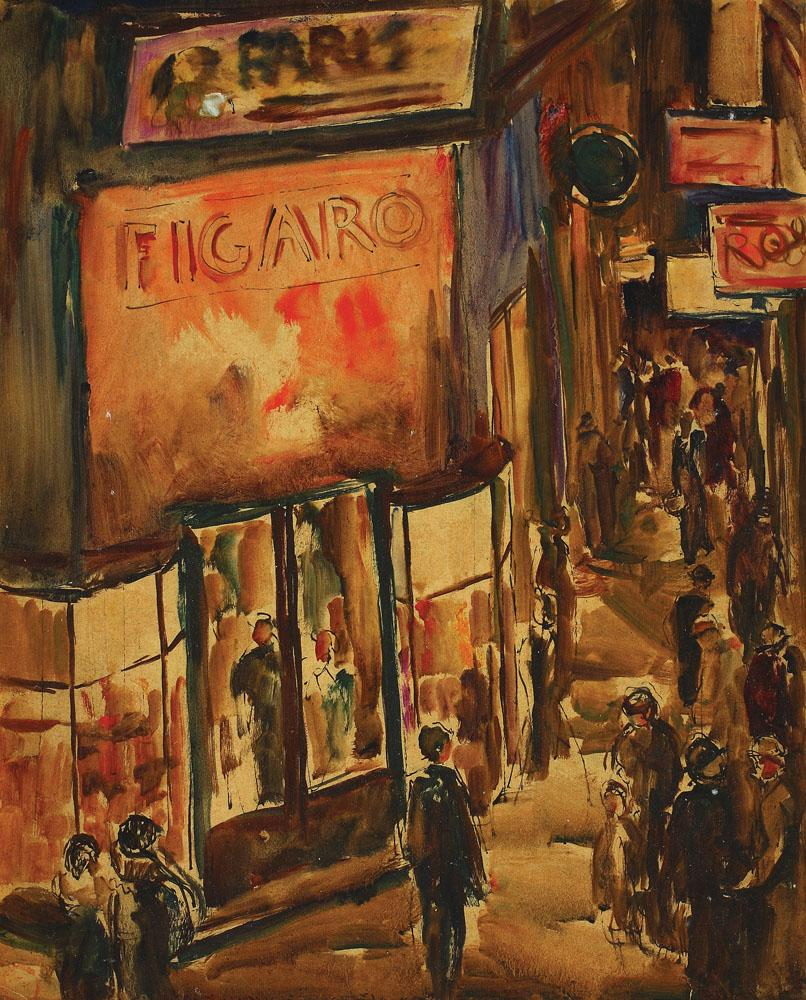Craft a story inspired by the image. In the heart of Paris, beneath the glowing FIGARO sign, Isabella hurried past the shop windows, her mind a flurry of anticipation and nerves. Today was the grand opening of her first exhibition at the adjacent gallery. As she passed the bustling crowds, she couldn't help but feel enveloped in the vibrant energy of the city that had inspired so much of her work. The mannequins in the display window seemed to echo the fashionable passersby, making the boundary between the artistic and the real world delightfully blurred. What might be going on in the lives of the individuals depicted in the painting? As the evening shadows lengthened, Madame Bertin adjusted her hat and smiled at the children playing beside her, their laughter a joyful crescendo amidst the city's symphony. Monsieur Armand, deep in conversation with an old friend, recounted tales from their youth, their gestures animated with nostalgia. Further down the street, a young artist named Claude sketched furiously, capturing the essence of the vibrant scene before him, dreaming of the day when his work might hang in the famed galleries of Montmartre. 